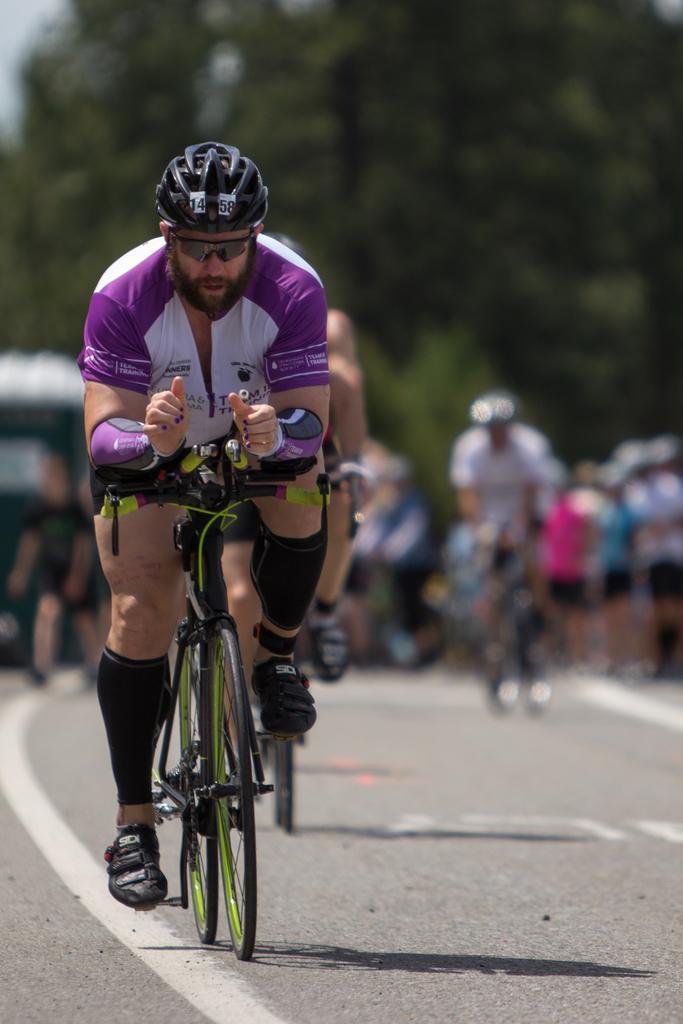In one or two sentences, can you explain what this image depicts? In this image On the left there is a man he is riding bicycle he wears t shirt, trouser and helmet. In the background there are many people, riding bicycles and some are watching them and there is road and trees. 